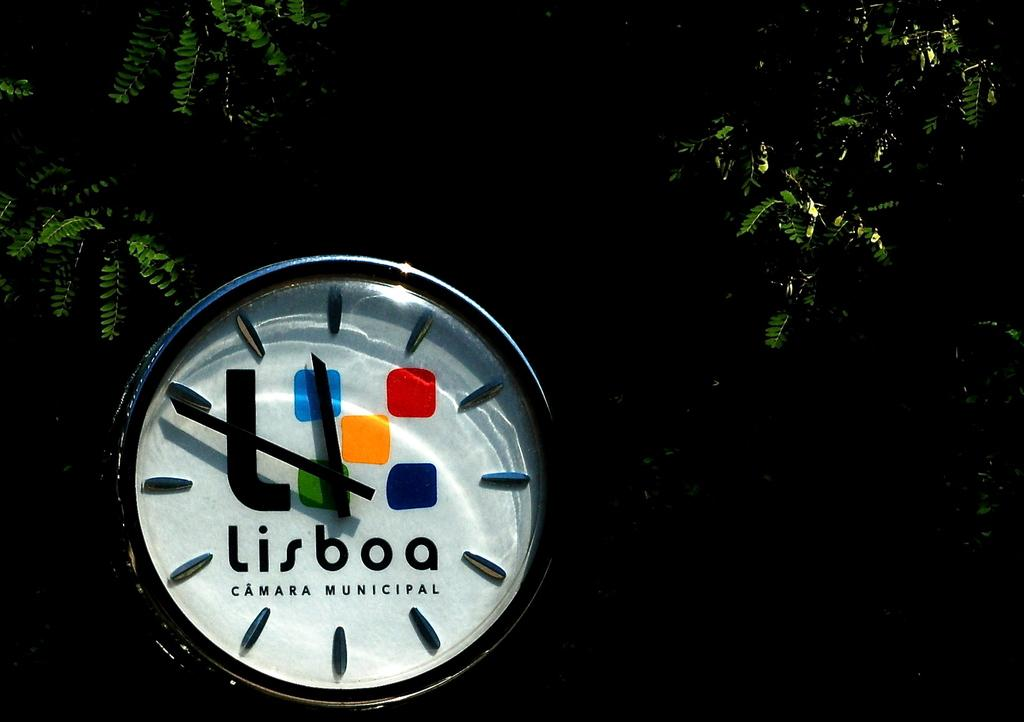<image>
Render a clear and concise summary of the photo. A colorful watch face displays Lisboa in black lettering. 